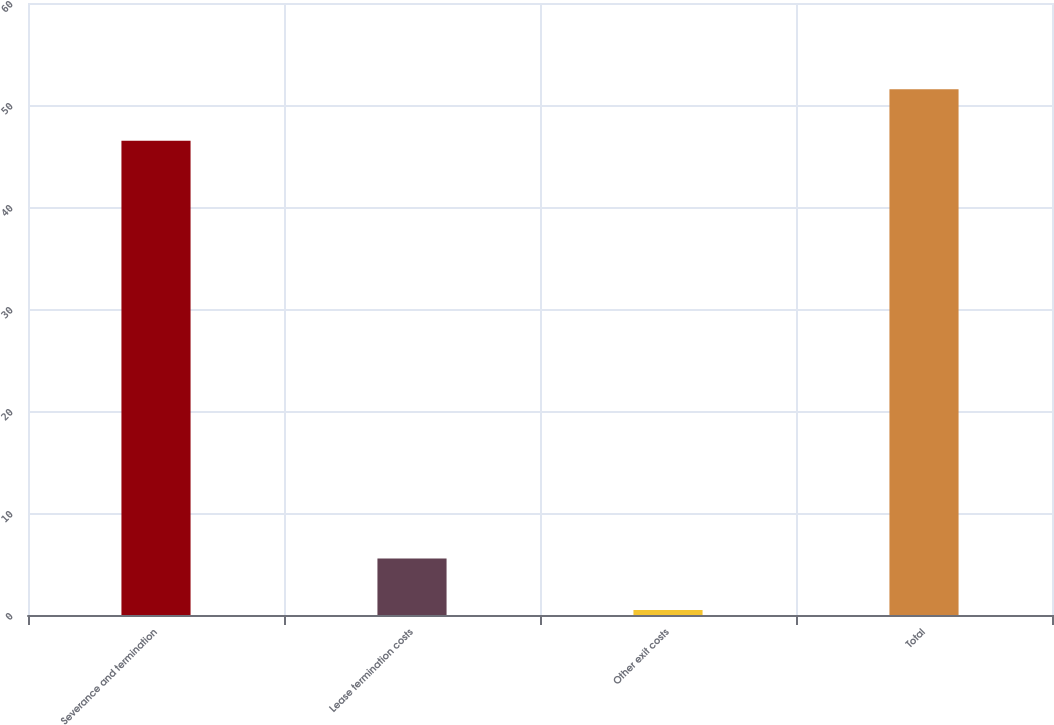Convert chart. <chart><loc_0><loc_0><loc_500><loc_500><bar_chart><fcel>Severance and termination<fcel>Lease termination costs<fcel>Other exit costs<fcel>Total<nl><fcel>46.5<fcel>5.54<fcel>0.5<fcel>51.54<nl></chart> 